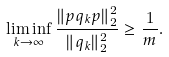Convert formula to latex. <formula><loc_0><loc_0><loc_500><loc_500>\liminf _ { k \rightarrow \infty } \frac { \| p q _ { k } p \| _ { 2 } ^ { 2 } } { \| q _ { k } \| _ { 2 } ^ { 2 } } \geq \frac { 1 } { m } .</formula> 